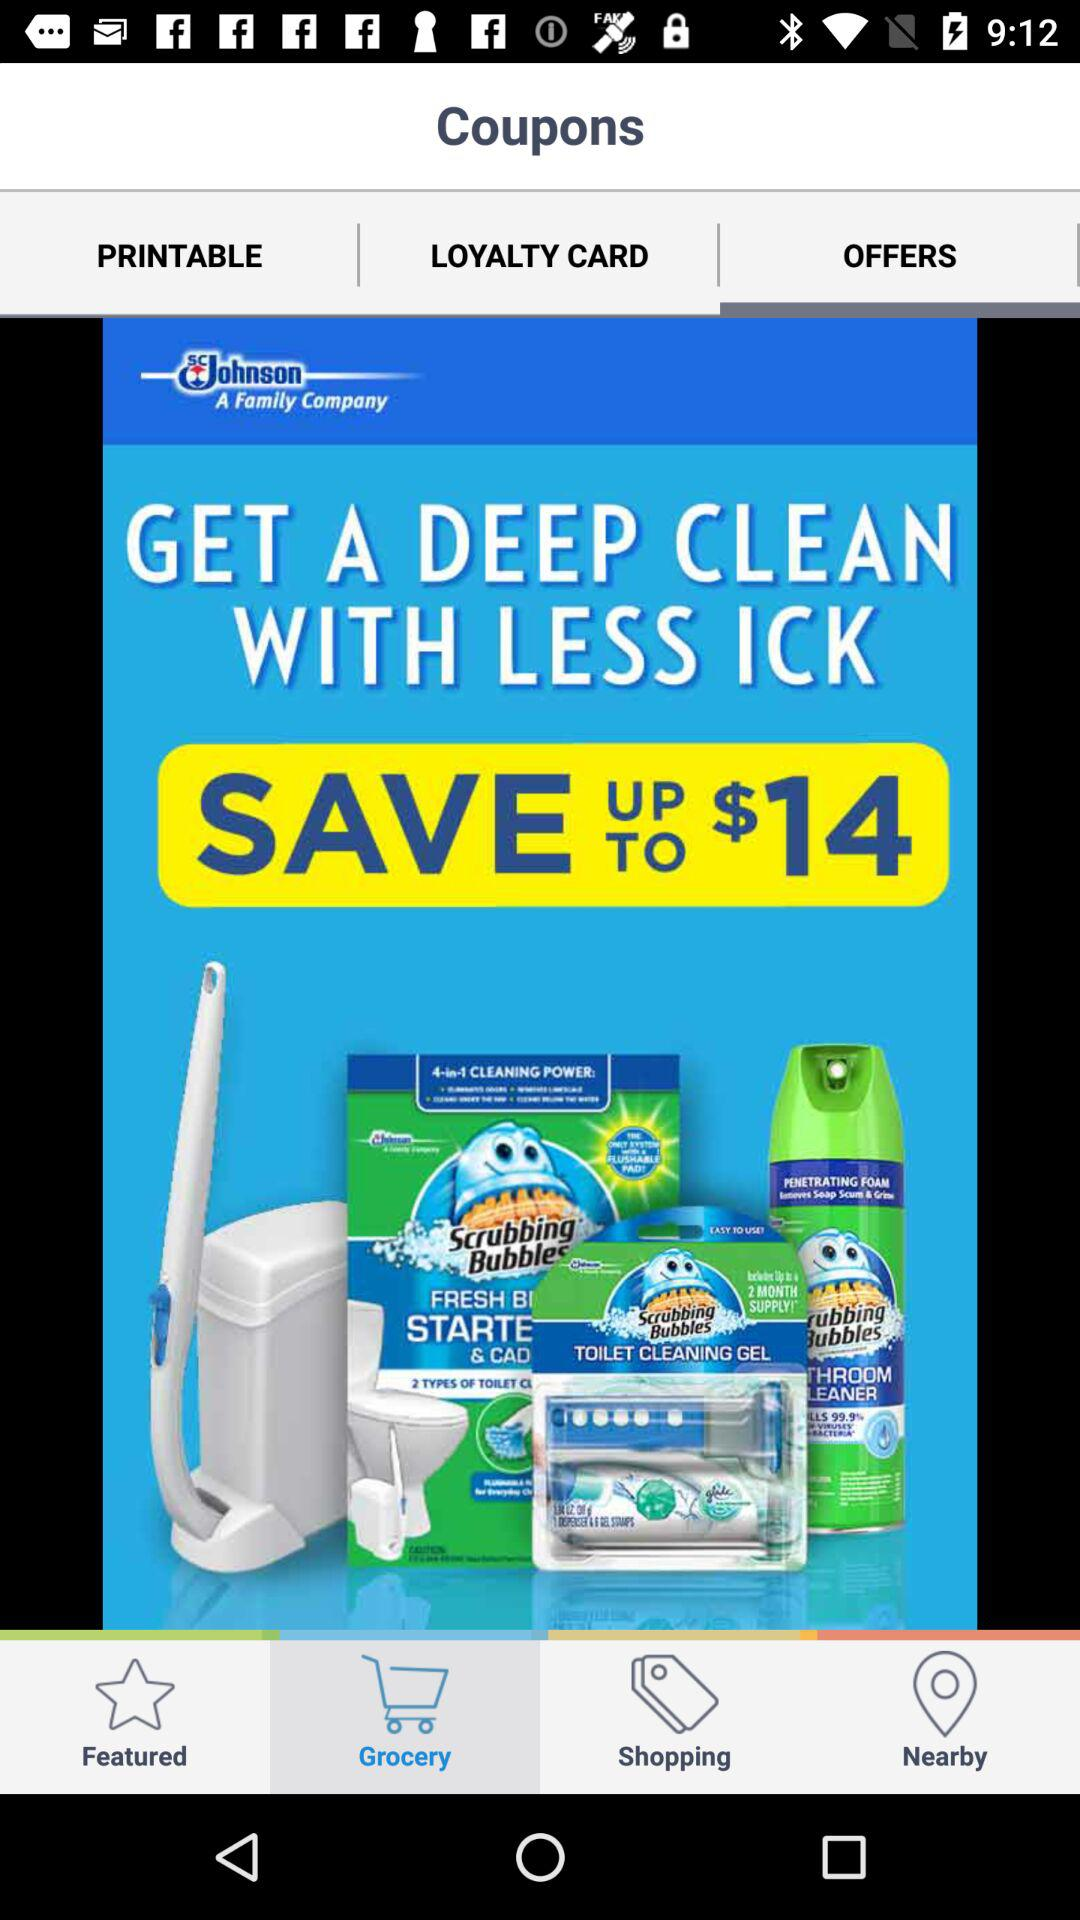How much money can I save by using the coupon?
Answer the question using a single word or phrase. $14 